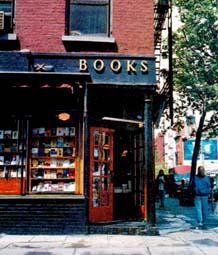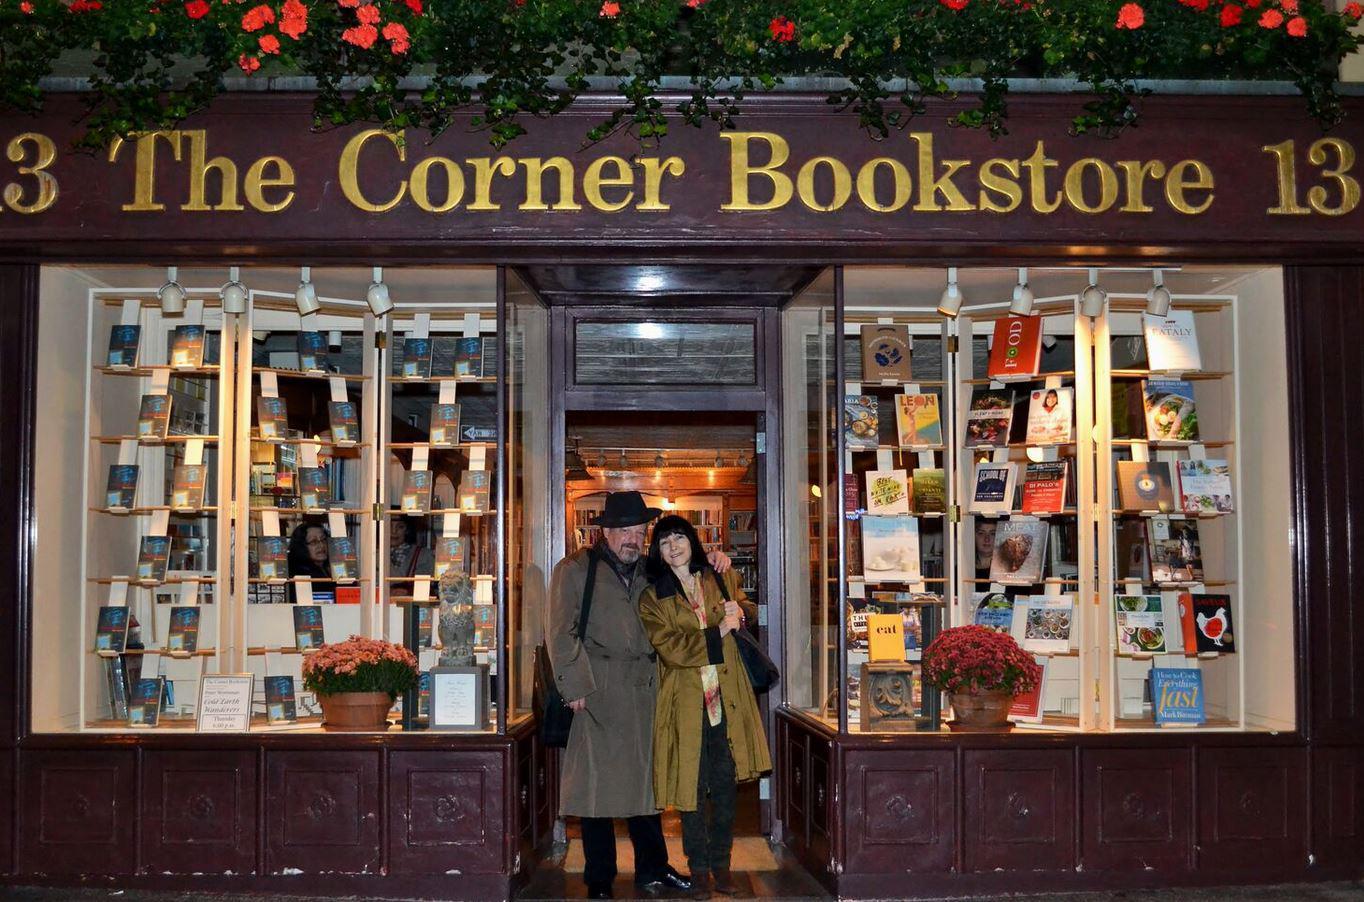The first image is the image on the left, the second image is the image on the right. Analyze the images presented: Is the assertion "In one image there is a bookstore on a street corner with a red door that is open." valid? Answer yes or no. Yes. The first image is the image on the left, the second image is the image on the right. Considering the images on both sides, is "There is one image taken of the inside of the bookstore" valid? Answer yes or no. No. 